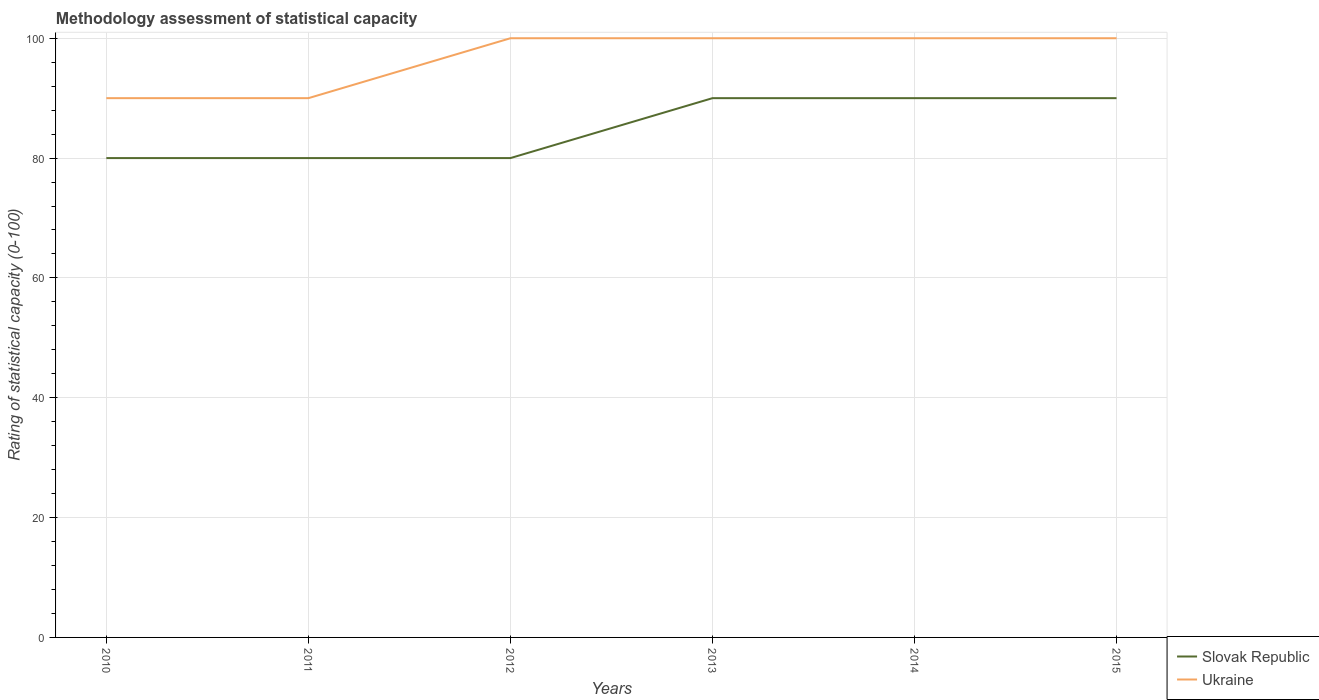Across all years, what is the maximum rating of statistical capacity in Slovak Republic?
Your answer should be compact. 80. In which year was the rating of statistical capacity in Ukraine maximum?
Offer a terse response. 2010. What is the total rating of statistical capacity in Slovak Republic in the graph?
Provide a short and direct response. -10. What is the difference between the highest and the second highest rating of statistical capacity in Ukraine?
Offer a very short reply. 10. Is the rating of statistical capacity in Slovak Republic strictly greater than the rating of statistical capacity in Ukraine over the years?
Make the answer very short. Yes. Does the graph contain grids?
Your response must be concise. Yes. Where does the legend appear in the graph?
Make the answer very short. Bottom right. What is the title of the graph?
Provide a succinct answer. Methodology assessment of statistical capacity. What is the label or title of the X-axis?
Make the answer very short. Years. What is the label or title of the Y-axis?
Offer a terse response. Rating of statistical capacity (0-100). What is the Rating of statistical capacity (0-100) in Slovak Republic in 2010?
Provide a succinct answer. 80. What is the Rating of statistical capacity (0-100) in Slovak Republic in 2011?
Offer a very short reply. 80. What is the Rating of statistical capacity (0-100) in Slovak Republic in 2013?
Make the answer very short. 90. What is the Rating of statistical capacity (0-100) in Ukraine in 2014?
Your response must be concise. 100. Across all years, what is the minimum Rating of statistical capacity (0-100) of Slovak Republic?
Provide a succinct answer. 80. What is the total Rating of statistical capacity (0-100) of Slovak Republic in the graph?
Give a very brief answer. 510. What is the total Rating of statistical capacity (0-100) of Ukraine in the graph?
Ensure brevity in your answer.  580. What is the difference between the Rating of statistical capacity (0-100) of Slovak Republic in 2010 and that in 2012?
Offer a very short reply. 0. What is the difference between the Rating of statistical capacity (0-100) of Ukraine in 2010 and that in 2012?
Your answer should be compact. -10. What is the difference between the Rating of statistical capacity (0-100) in Ukraine in 2010 and that in 2013?
Your response must be concise. -10. What is the difference between the Rating of statistical capacity (0-100) of Slovak Republic in 2010 and that in 2014?
Keep it short and to the point. -10. What is the difference between the Rating of statistical capacity (0-100) of Slovak Republic in 2010 and that in 2015?
Offer a very short reply. -10. What is the difference between the Rating of statistical capacity (0-100) of Ukraine in 2010 and that in 2015?
Make the answer very short. -10. What is the difference between the Rating of statistical capacity (0-100) of Slovak Republic in 2011 and that in 2012?
Your response must be concise. 0. What is the difference between the Rating of statistical capacity (0-100) in Ukraine in 2011 and that in 2012?
Provide a short and direct response. -10. What is the difference between the Rating of statistical capacity (0-100) in Slovak Republic in 2011 and that in 2014?
Provide a succinct answer. -10. What is the difference between the Rating of statistical capacity (0-100) in Slovak Republic in 2011 and that in 2015?
Keep it short and to the point. -10. What is the difference between the Rating of statistical capacity (0-100) of Slovak Republic in 2012 and that in 2013?
Make the answer very short. -10. What is the difference between the Rating of statistical capacity (0-100) of Ukraine in 2012 and that in 2013?
Ensure brevity in your answer.  0. What is the difference between the Rating of statistical capacity (0-100) in Slovak Republic in 2012 and that in 2015?
Offer a terse response. -10. What is the difference between the Rating of statistical capacity (0-100) in Ukraine in 2012 and that in 2015?
Your response must be concise. 0. What is the difference between the Rating of statistical capacity (0-100) in Slovak Republic in 2013 and that in 2014?
Provide a succinct answer. 0. What is the difference between the Rating of statistical capacity (0-100) of Ukraine in 2013 and that in 2014?
Offer a terse response. 0. What is the difference between the Rating of statistical capacity (0-100) in Slovak Republic in 2013 and that in 2015?
Your answer should be very brief. 0. What is the difference between the Rating of statistical capacity (0-100) in Slovak Republic in 2014 and that in 2015?
Offer a very short reply. 0. What is the difference between the Rating of statistical capacity (0-100) in Ukraine in 2014 and that in 2015?
Make the answer very short. 0. What is the difference between the Rating of statistical capacity (0-100) in Slovak Republic in 2010 and the Rating of statistical capacity (0-100) in Ukraine in 2011?
Your answer should be very brief. -10. What is the difference between the Rating of statistical capacity (0-100) of Slovak Republic in 2010 and the Rating of statistical capacity (0-100) of Ukraine in 2012?
Your answer should be very brief. -20. What is the difference between the Rating of statistical capacity (0-100) in Slovak Republic in 2010 and the Rating of statistical capacity (0-100) in Ukraine in 2013?
Offer a terse response. -20. What is the difference between the Rating of statistical capacity (0-100) of Slovak Republic in 2011 and the Rating of statistical capacity (0-100) of Ukraine in 2014?
Offer a very short reply. -20. What is the difference between the Rating of statistical capacity (0-100) in Slovak Republic in 2012 and the Rating of statistical capacity (0-100) in Ukraine in 2013?
Your answer should be very brief. -20. What is the difference between the Rating of statistical capacity (0-100) in Slovak Republic in 2012 and the Rating of statistical capacity (0-100) in Ukraine in 2014?
Ensure brevity in your answer.  -20. What is the difference between the Rating of statistical capacity (0-100) of Slovak Republic in 2013 and the Rating of statistical capacity (0-100) of Ukraine in 2015?
Make the answer very short. -10. What is the average Rating of statistical capacity (0-100) of Slovak Republic per year?
Offer a very short reply. 85. What is the average Rating of statistical capacity (0-100) in Ukraine per year?
Ensure brevity in your answer.  96.67. In the year 2010, what is the difference between the Rating of statistical capacity (0-100) of Slovak Republic and Rating of statistical capacity (0-100) of Ukraine?
Your response must be concise. -10. In the year 2011, what is the difference between the Rating of statistical capacity (0-100) in Slovak Republic and Rating of statistical capacity (0-100) in Ukraine?
Your answer should be compact. -10. In the year 2012, what is the difference between the Rating of statistical capacity (0-100) in Slovak Republic and Rating of statistical capacity (0-100) in Ukraine?
Give a very brief answer. -20. In the year 2013, what is the difference between the Rating of statistical capacity (0-100) in Slovak Republic and Rating of statistical capacity (0-100) in Ukraine?
Ensure brevity in your answer.  -10. In the year 2015, what is the difference between the Rating of statistical capacity (0-100) of Slovak Republic and Rating of statistical capacity (0-100) of Ukraine?
Keep it short and to the point. -10. What is the ratio of the Rating of statistical capacity (0-100) in Slovak Republic in 2010 to that in 2011?
Your answer should be compact. 1. What is the ratio of the Rating of statistical capacity (0-100) of Ukraine in 2010 to that in 2011?
Your answer should be very brief. 1. What is the ratio of the Rating of statistical capacity (0-100) in Slovak Republic in 2010 to that in 2012?
Ensure brevity in your answer.  1. What is the ratio of the Rating of statistical capacity (0-100) of Ukraine in 2010 to that in 2013?
Your response must be concise. 0.9. What is the ratio of the Rating of statistical capacity (0-100) of Ukraine in 2010 to that in 2015?
Your answer should be compact. 0.9. What is the ratio of the Rating of statistical capacity (0-100) in Ukraine in 2011 to that in 2012?
Your answer should be very brief. 0.9. What is the ratio of the Rating of statistical capacity (0-100) in Slovak Republic in 2011 to that in 2013?
Offer a terse response. 0.89. What is the ratio of the Rating of statistical capacity (0-100) of Slovak Republic in 2011 to that in 2014?
Ensure brevity in your answer.  0.89. What is the ratio of the Rating of statistical capacity (0-100) in Ukraine in 2011 to that in 2014?
Provide a succinct answer. 0.9. What is the ratio of the Rating of statistical capacity (0-100) of Slovak Republic in 2011 to that in 2015?
Ensure brevity in your answer.  0.89. What is the ratio of the Rating of statistical capacity (0-100) in Ukraine in 2011 to that in 2015?
Provide a short and direct response. 0.9. What is the ratio of the Rating of statistical capacity (0-100) in Slovak Republic in 2012 to that in 2013?
Keep it short and to the point. 0.89. What is the ratio of the Rating of statistical capacity (0-100) of Ukraine in 2012 to that in 2013?
Offer a terse response. 1. What is the ratio of the Rating of statistical capacity (0-100) of Ukraine in 2013 to that in 2014?
Give a very brief answer. 1. What is the ratio of the Rating of statistical capacity (0-100) of Ukraine in 2013 to that in 2015?
Give a very brief answer. 1. What is the ratio of the Rating of statistical capacity (0-100) in Slovak Republic in 2014 to that in 2015?
Provide a succinct answer. 1. What is the difference between the highest and the second highest Rating of statistical capacity (0-100) of Ukraine?
Provide a succinct answer. 0. What is the difference between the highest and the lowest Rating of statistical capacity (0-100) of Slovak Republic?
Provide a short and direct response. 10. What is the difference between the highest and the lowest Rating of statistical capacity (0-100) of Ukraine?
Your answer should be very brief. 10. 